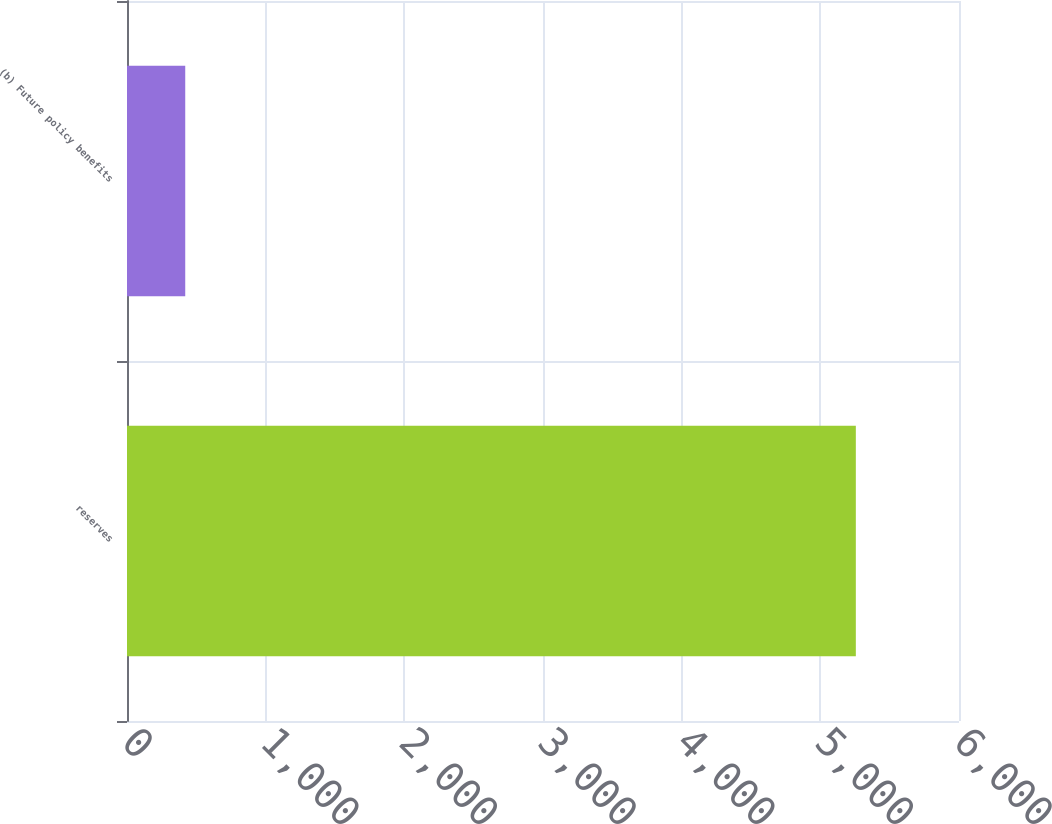<chart> <loc_0><loc_0><loc_500><loc_500><bar_chart><fcel>reserves<fcel>(b) Future policy benefits<nl><fcel>5256<fcel>420<nl></chart> 